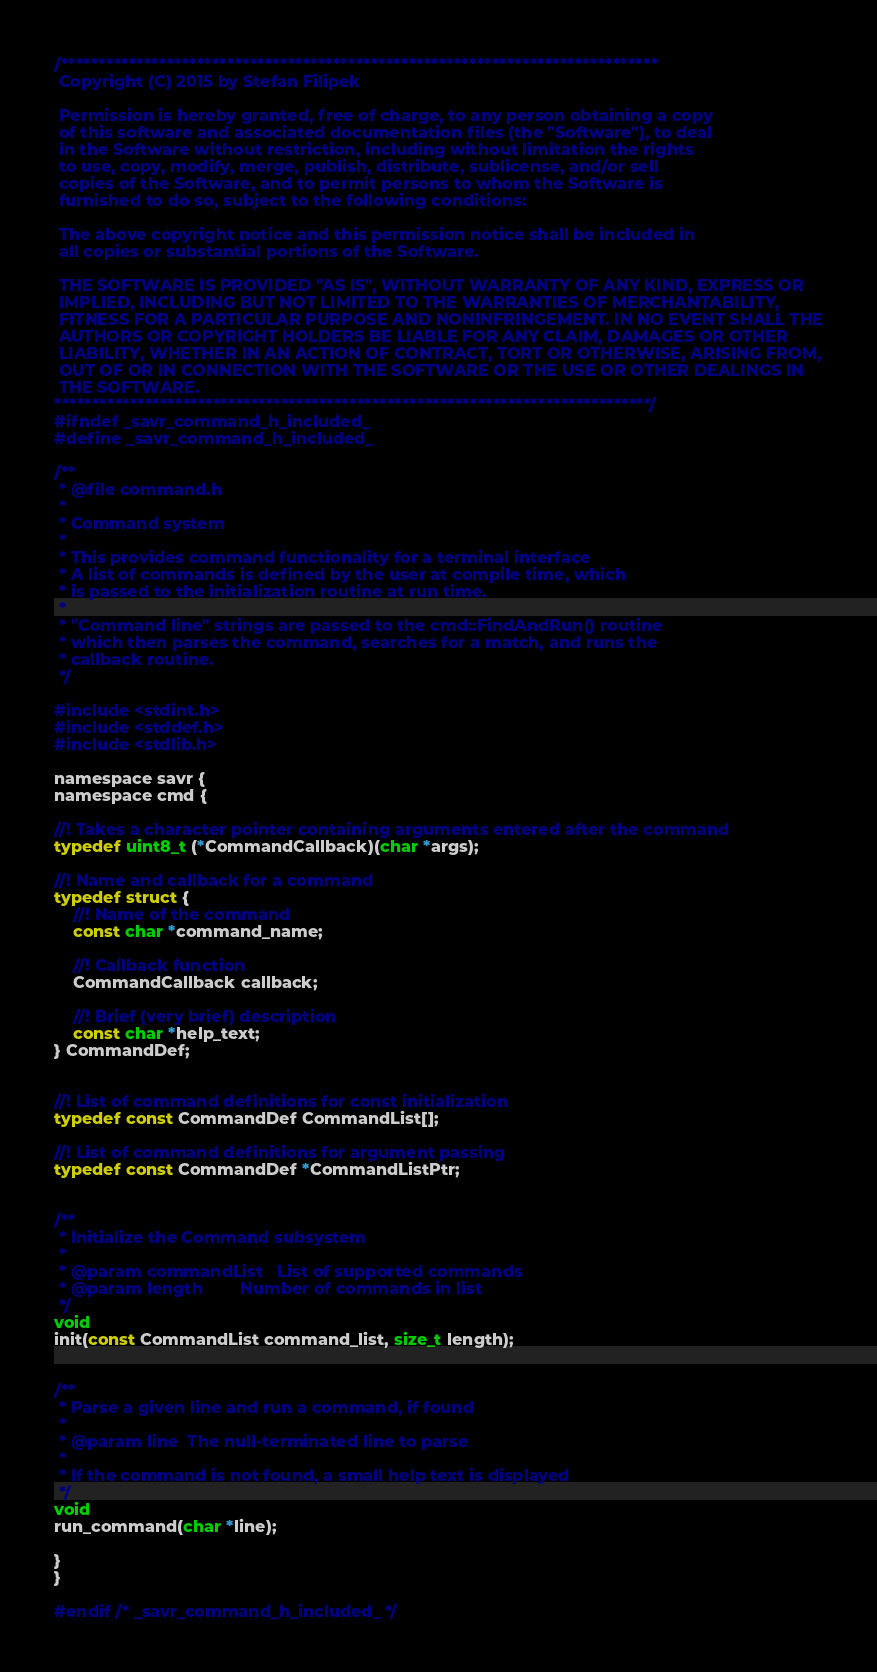Convert code to text. <code><loc_0><loc_0><loc_500><loc_500><_C_>/*******************************************************************************
 Copyright (C) 2015 by Stefan Filipek

 Permission is hereby granted, free of charge, to any person obtaining a copy
 of this software and associated documentation files (the "Software"), to deal
 in the Software without restriction, including without limitation the rights
 to use, copy, modify, merge, publish, distribute, sublicense, and/or sell
 copies of the Software, and to permit persons to whom the Software is
 furnished to do so, subject to the following conditions:

 The above copyright notice and this permission notice shall be included in
 all copies or substantial portions of the Software.

 THE SOFTWARE IS PROVIDED "AS IS", WITHOUT WARRANTY OF ANY KIND, EXPRESS OR
 IMPLIED, INCLUDING BUT NOT LIMITED TO THE WARRANTIES OF MERCHANTABILITY,
 FITNESS FOR A PARTICULAR PURPOSE AND NONINFRINGEMENT. IN NO EVENT SHALL THE
 AUTHORS OR COPYRIGHT HOLDERS BE LIABLE FOR ANY CLAIM, DAMAGES OR OTHER
 LIABILITY, WHETHER IN AN ACTION OF CONTRACT, TORT OR OTHERWISE, ARISING FROM,
 OUT OF OR IN CONNECTION WITH THE SOFTWARE OR THE USE OR OTHER DEALINGS IN
 THE SOFTWARE.
*******************************************************************************/
#ifndef _savr_command_h_included_
#define _savr_command_h_included_

/**
 * @file command.h
 *
 * Command system
 *
 * This provides command functionality for a terminal interface
 * A list of commands is defined by the user at compile time, which
 * is passed to the initialization routine at run time.
 *
 * "Command line" strings are passed to the cmd::FindAndRun() routine
 * which then parses the command, searches for a match, and runs the
 * callback routine.
 */

#include <stdint.h>
#include <stddef.h>
#include <stdlib.h>

namespace savr {
namespace cmd {

//! Takes a character pointer containing arguments entered after the command
typedef uint8_t (*CommandCallback)(char *args);

//! Name and callback for a command
typedef struct {
    //! Name of the command
    const char *command_name;

    //! Callback function
    CommandCallback callback;

    //! Brief (very brief) description
    const char *help_text;
} CommandDef;


//! List of command definitions for const initialization
typedef const CommandDef CommandList[];

//! List of command definitions for argument passing
typedef const CommandDef *CommandListPtr;


/**
 * Initialize the Command subsystem
 *
 * @param commandList   List of supported commands
 * @param length        Number of commands in list
 */
void
init(const CommandList command_list, size_t length);


/**
 * Parse a given line and run a command, if found
 *
 * @param line  The null-terminated line to parse
 *
 * If the command is not found, a small help text is displayed
 */
void
run_command(char *line);

}
}

#endif /* _savr_command_h_included_ */
</code> 